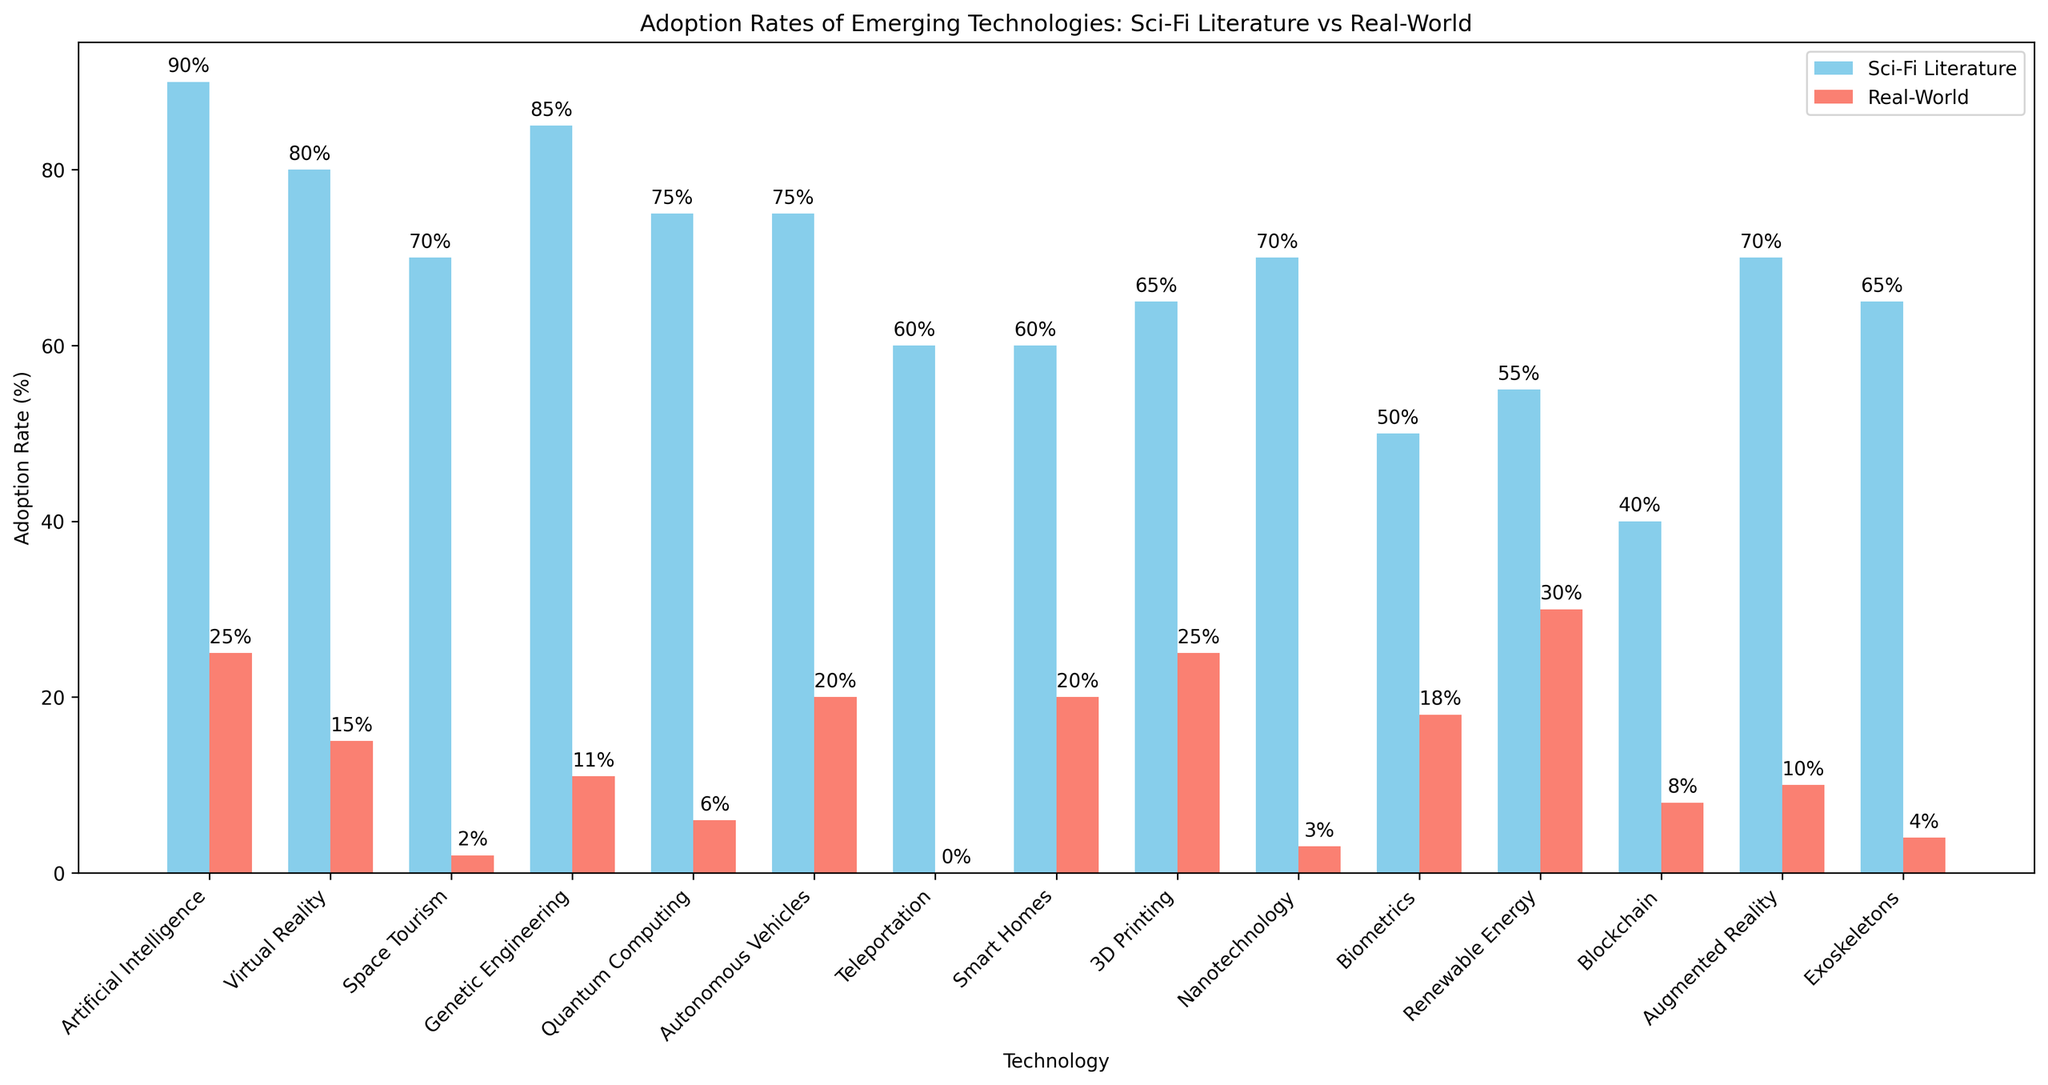What is the technology with the highest adoption rate in sci-fi literature? According to the figure, Artificial Intelligence has the highest adoption rate in sci-fi literature at 90%.
Answer: Artificial Intelligence Which technology has the closest real-world adoption rate to its adoption rate in sci-fi literature? By comparing the bars, Smart Homes show the closest real-world adoption rate (20%) to its sci-fi literature adoption rate (60%), with a difference of 40%.
Answer: Smart Homes How much lower is the real-world adoption rate of Space Tourism compared to its science fiction adoption rate? The adoption rate for Space Tourism in sci-fi literature is 70%, while in the real world, it is only 2%. The difference between these two rates is 70% - 2% = 68%.
Answer: 68% Which technology has the greatest difference between its adoption rate in sci-fi literature and the real world? Comparing all the differences, Space Tourism has the greatest difference: 70% (sci-fi) - 2% (real-world) = 68%.
Answer: Space Tourism Sort the technologies by real-world adoption rates in ascending order. The real-world adoption rates in ascending order are: Teleportation (0%), Space Tourism (2%), Nanotechnology (3%), Exoskeletons (4%), Quantum Computing (6%), Blockchain (8%), Augmented Reality (10%), Genetic Engineering (11%), Virtual Reality (15%), Biometrics (18%), Autonomous Vehicles (20%), Smart Homes (20%), Artificial Intelligence (25%), 3D Printing (25%), Renewable Energy (30%).
Answer: Teleportation, Space Tourism, Nanotechnology, Exoskeletons, Quantum Computing, Blockchain, Augmented Reality, Genetic Engineering, Virtual Reality, Biometrics, Autonomous Vehicles, Smart Homes, Artificial Intelligence, 3D Printing, Renewable Energy Is the adoption rate of Quantum Computing higher or lower than Autonomous Vehicles in sci-fi literature? In sci-fi literature, the adoption rate of Quantum Computing is 75%, which is equal to the adoption rate of Autonomous Vehicles.
Answer: Equal What is the average real-world adoption rate across all technologies? Sum all real-world adoption rates (25 + 15 + 2 + 11 + 6 + 20 + 0 + 20 + 25 + 3 + 18 + 30 + 8 + 10 + 4 = 197) and divide by the number of technologies (15). The average real-world adoption rate is 197 / 15 ≈ 13.13%.
Answer: 13.13% Compare the adoption rates of Artificial Intelligence and Virtual Reality in both sci-fi literature and the real world. In sci-fi literature, Artificial Intelligence has an adoption rate of 90%, and Virtual Reality has 80%. In the real world, Artificial Intelligence has 25%, and Virtual Reality has 15%. Thus, Artificial Intelligence is higher in both categories.
Answer: Artificial Intelligence Which technologies have real-world adoption rates above the average real-world rate? The average real-world adoption rate is ~13.13%. Technologies with rates above this are: Artificial Intelligence (25%), 3D Printing (25%), Smart Homes (20%), Autonomous Vehicles (20%), Biometrics (18%), Renewable Energy (30%).
Answer: Artificial Intelligence, 3D Printing, Smart Homes, Autonomous Vehicles, Biometrics, Renewable Energy 